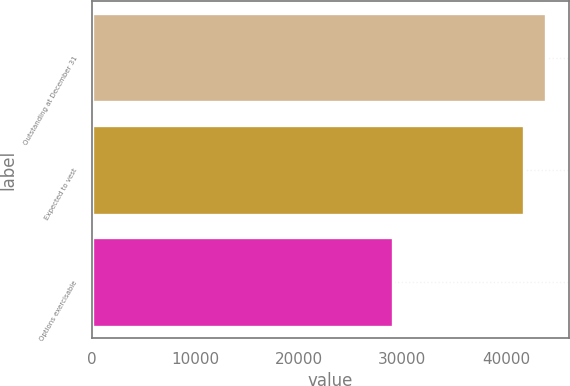<chart> <loc_0><loc_0><loc_500><loc_500><bar_chart><fcel>Outstanding at December 31<fcel>Expected to vest<fcel>Options exercisable<nl><fcel>43907<fcel>41749<fcel>29051<nl></chart> 